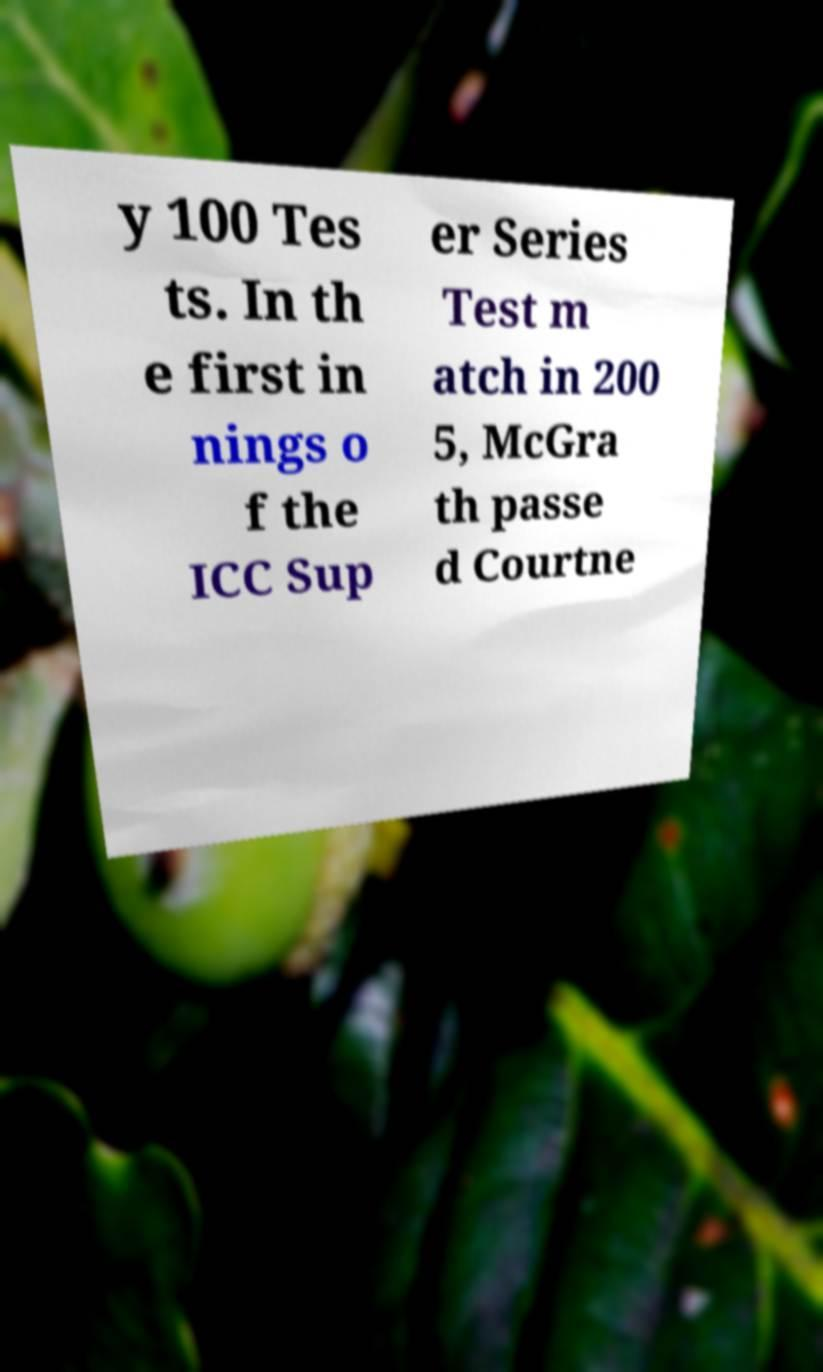Please read and relay the text visible in this image. What does it say? y 100 Tes ts. In th e first in nings o f the ICC Sup er Series Test m atch in 200 5, McGra th passe d Courtne 